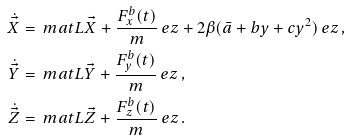<formula> <loc_0><loc_0><loc_500><loc_500>\dot { \vec { X } } & = \ m a t { L } \vec { X } + \frac { F ^ { b } _ { x } ( t ) } { m } \ e z + 2 \beta ( \bar { a } + b y + c y ^ { 2 } ) \ e z \, , \\ \dot { \vec { Y } } & = \ m a t { L } \vec { Y } + \frac { F ^ { b } _ { y } ( t ) } { m } \ e z \, , \\ \dot { \vec { Z } } & = \ m a t { L } \vec { Z } + \frac { F ^ { b } _ { z } ( t ) } { m } \ e z \, .</formula> 